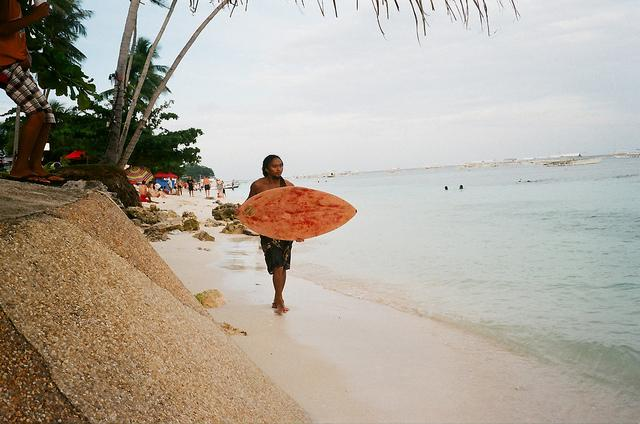Why is the man on the beach holding the object?

Choices:
A) to dance
B) to ski
C) to surf
D) to swim to surf 